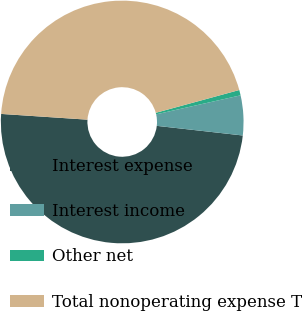Convert chart. <chart><loc_0><loc_0><loc_500><loc_500><pie_chart><fcel>Interest expense<fcel>Interest income<fcel>Other net<fcel>Total nonoperating expense T<nl><fcel>49.28%<fcel>5.3%<fcel>0.72%<fcel>44.7%<nl></chart> 